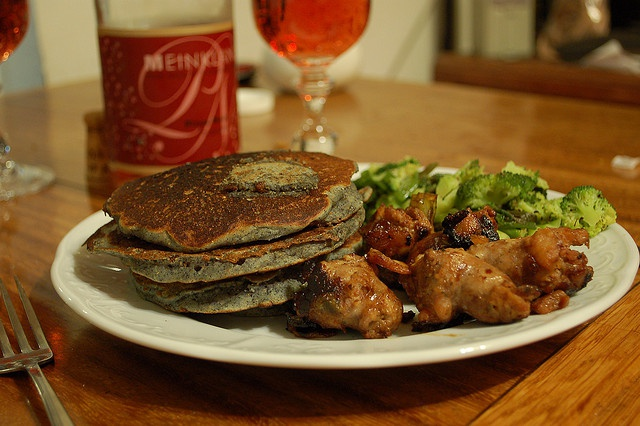Describe the objects in this image and their specific colors. I can see dining table in maroon, olive, and black tones, dining table in maroon, olive, and tan tones, bottle in maroon, brown, and tan tones, broccoli in maroon, olive, and black tones, and wine glass in maroon, brown, red, and tan tones in this image. 